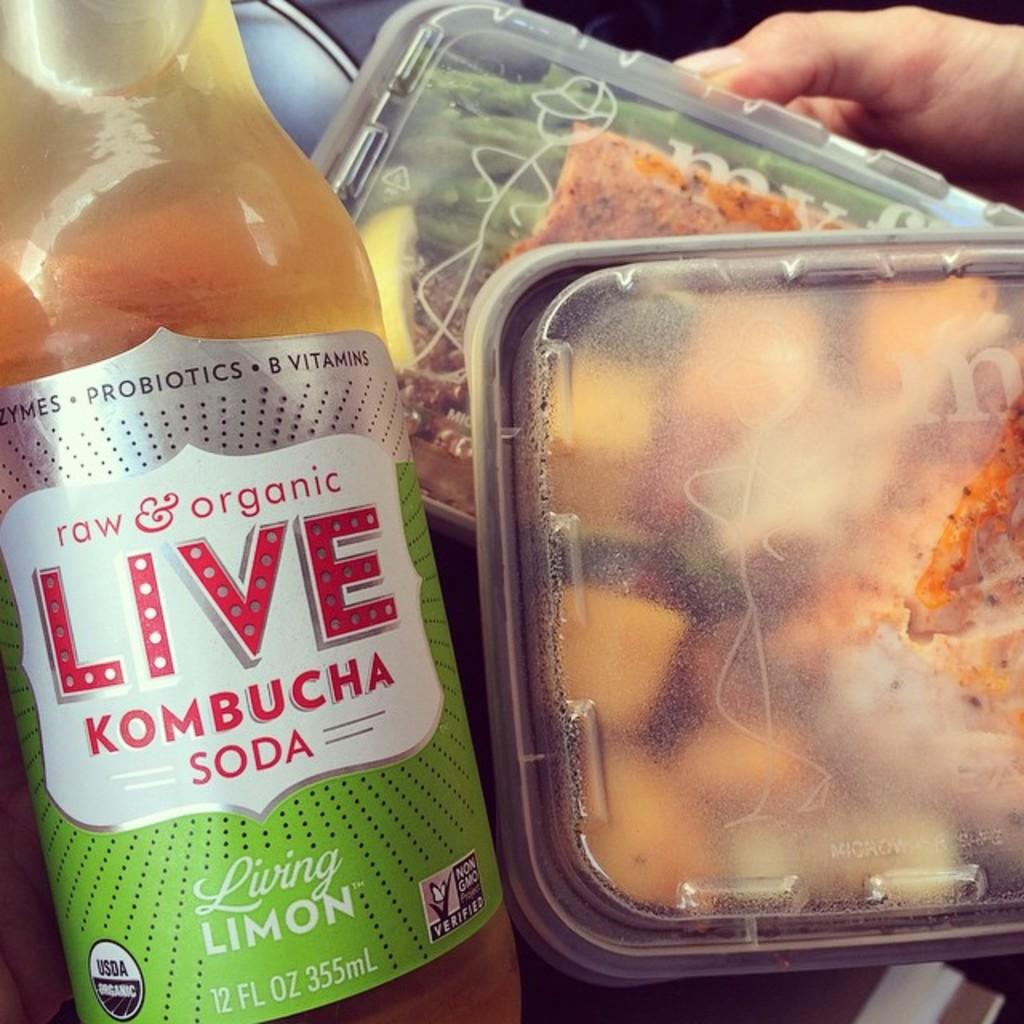<image>
Present a compact description of the photo's key features. A Live Kombucha Soda with some closed containers of foods 